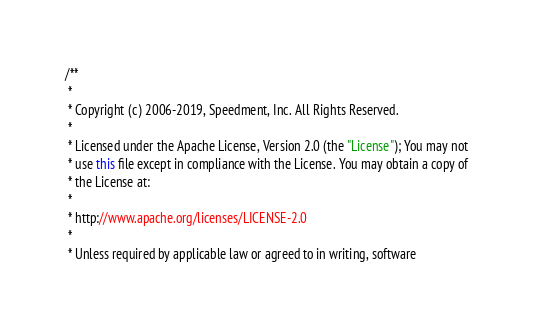Convert code to text. <code><loc_0><loc_0><loc_500><loc_500><_Java_>/**
 *
 * Copyright (c) 2006-2019, Speedment, Inc. All Rights Reserved.
 *
 * Licensed under the Apache License, Version 2.0 (the "License"); You may not
 * use this file except in compliance with the License. You may obtain a copy of
 * the License at:
 *
 * http://www.apache.org/licenses/LICENSE-2.0
 *
 * Unless required by applicable law or agreed to in writing, software</code> 